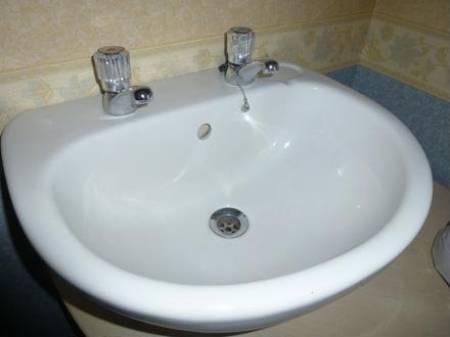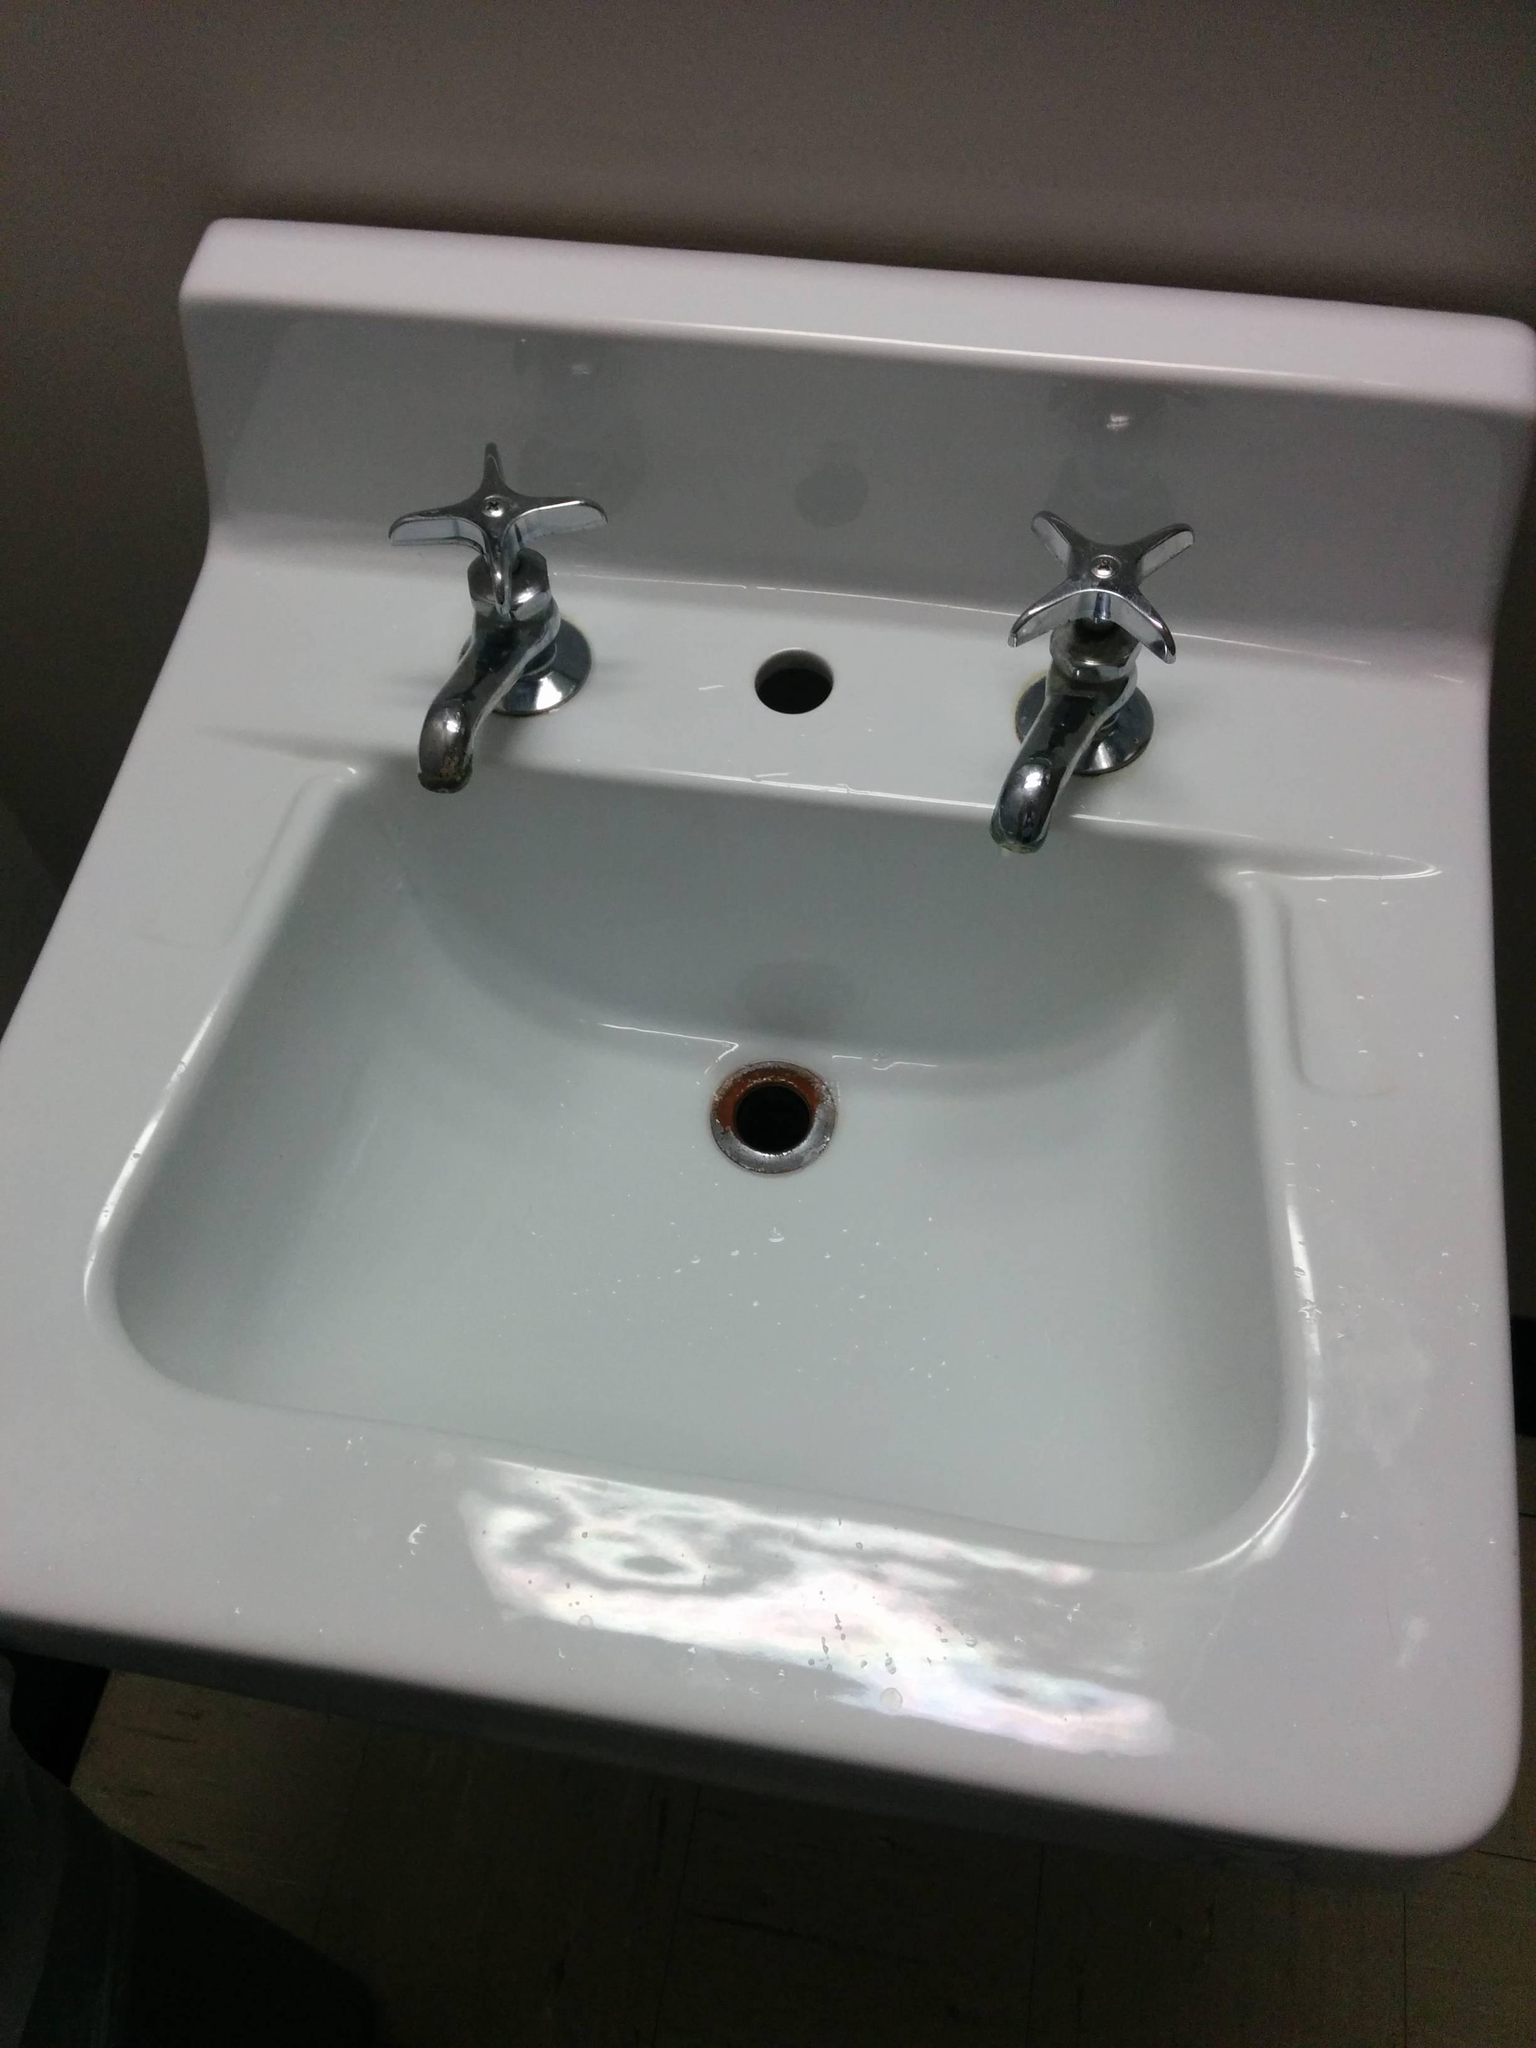The first image is the image on the left, the second image is the image on the right. Analyze the images presented: Is the assertion "There are two basins on the counter in the image on the right." valid? Answer yes or no. No. The first image is the image on the left, the second image is the image on the right. Evaluate the accuracy of this statement regarding the images: "A bathroom double sink installation has one upright chrome faucet fixture situated behind the bowl of each sink". Is it true? Answer yes or no. No. 